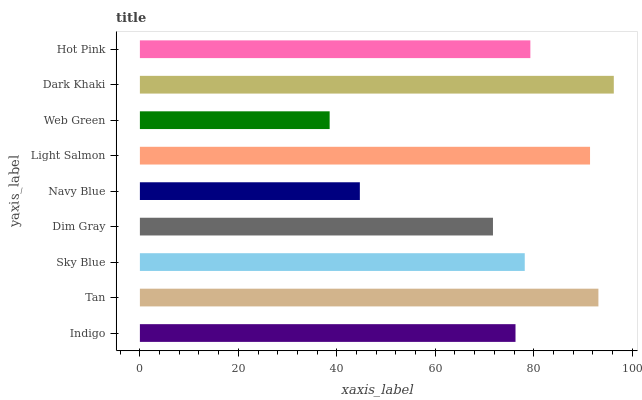Is Web Green the minimum?
Answer yes or no. Yes. Is Dark Khaki the maximum?
Answer yes or no. Yes. Is Tan the minimum?
Answer yes or no. No. Is Tan the maximum?
Answer yes or no. No. Is Tan greater than Indigo?
Answer yes or no. Yes. Is Indigo less than Tan?
Answer yes or no. Yes. Is Indigo greater than Tan?
Answer yes or no. No. Is Tan less than Indigo?
Answer yes or no. No. Is Sky Blue the high median?
Answer yes or no. Yes. Is Sky Blue the low median?
Answer yes or no. Yes. Is Navy Blue the high median?
Answer yes or no. No. Is Tan the low median?
Answer yes or no. No. 